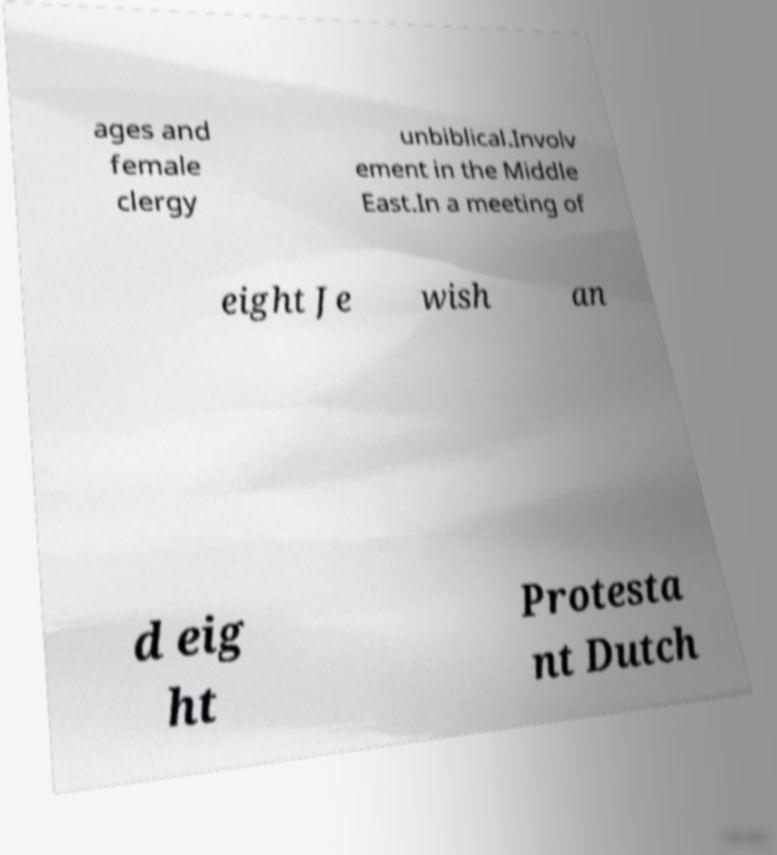What messages or text are displayed in this image? I need them in a readable, typed format. ages and female clergy unbiblical.Involv ement in the Middle East.In a meeting of eight Je wish an d eig ht Protesta nt Dutch 